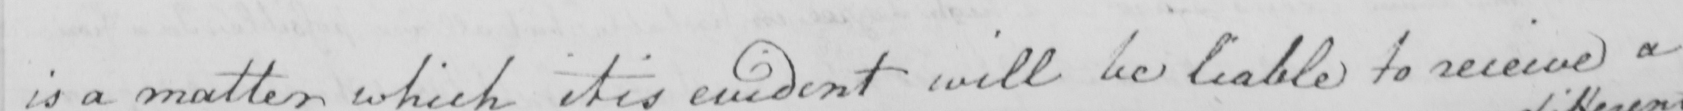What is written in this line of handwriting? is a matter which it is evident will be liable to receive a 